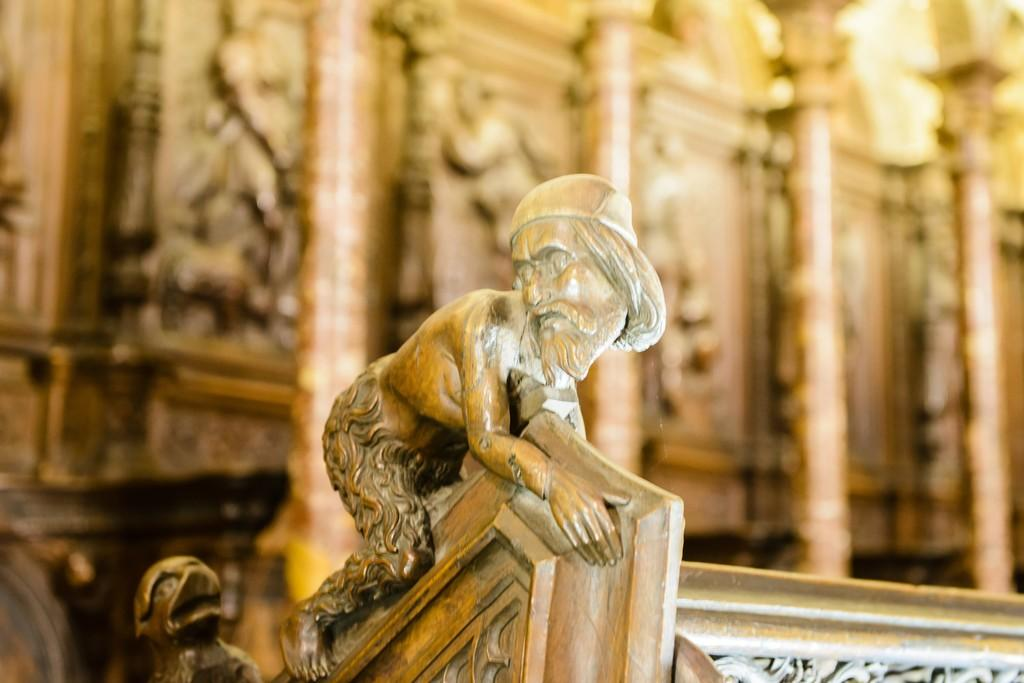What type of sculpture is present in the image? There is a wooden carved sculpture in the image. What can be seen in the background of the image? There are wooden carved designs in the background of the image. What tooth is responsible for smashing the wooden carved sculpture in the image? There is no tooth present in the image, and the wooden carved sculpture is not being smashed. 